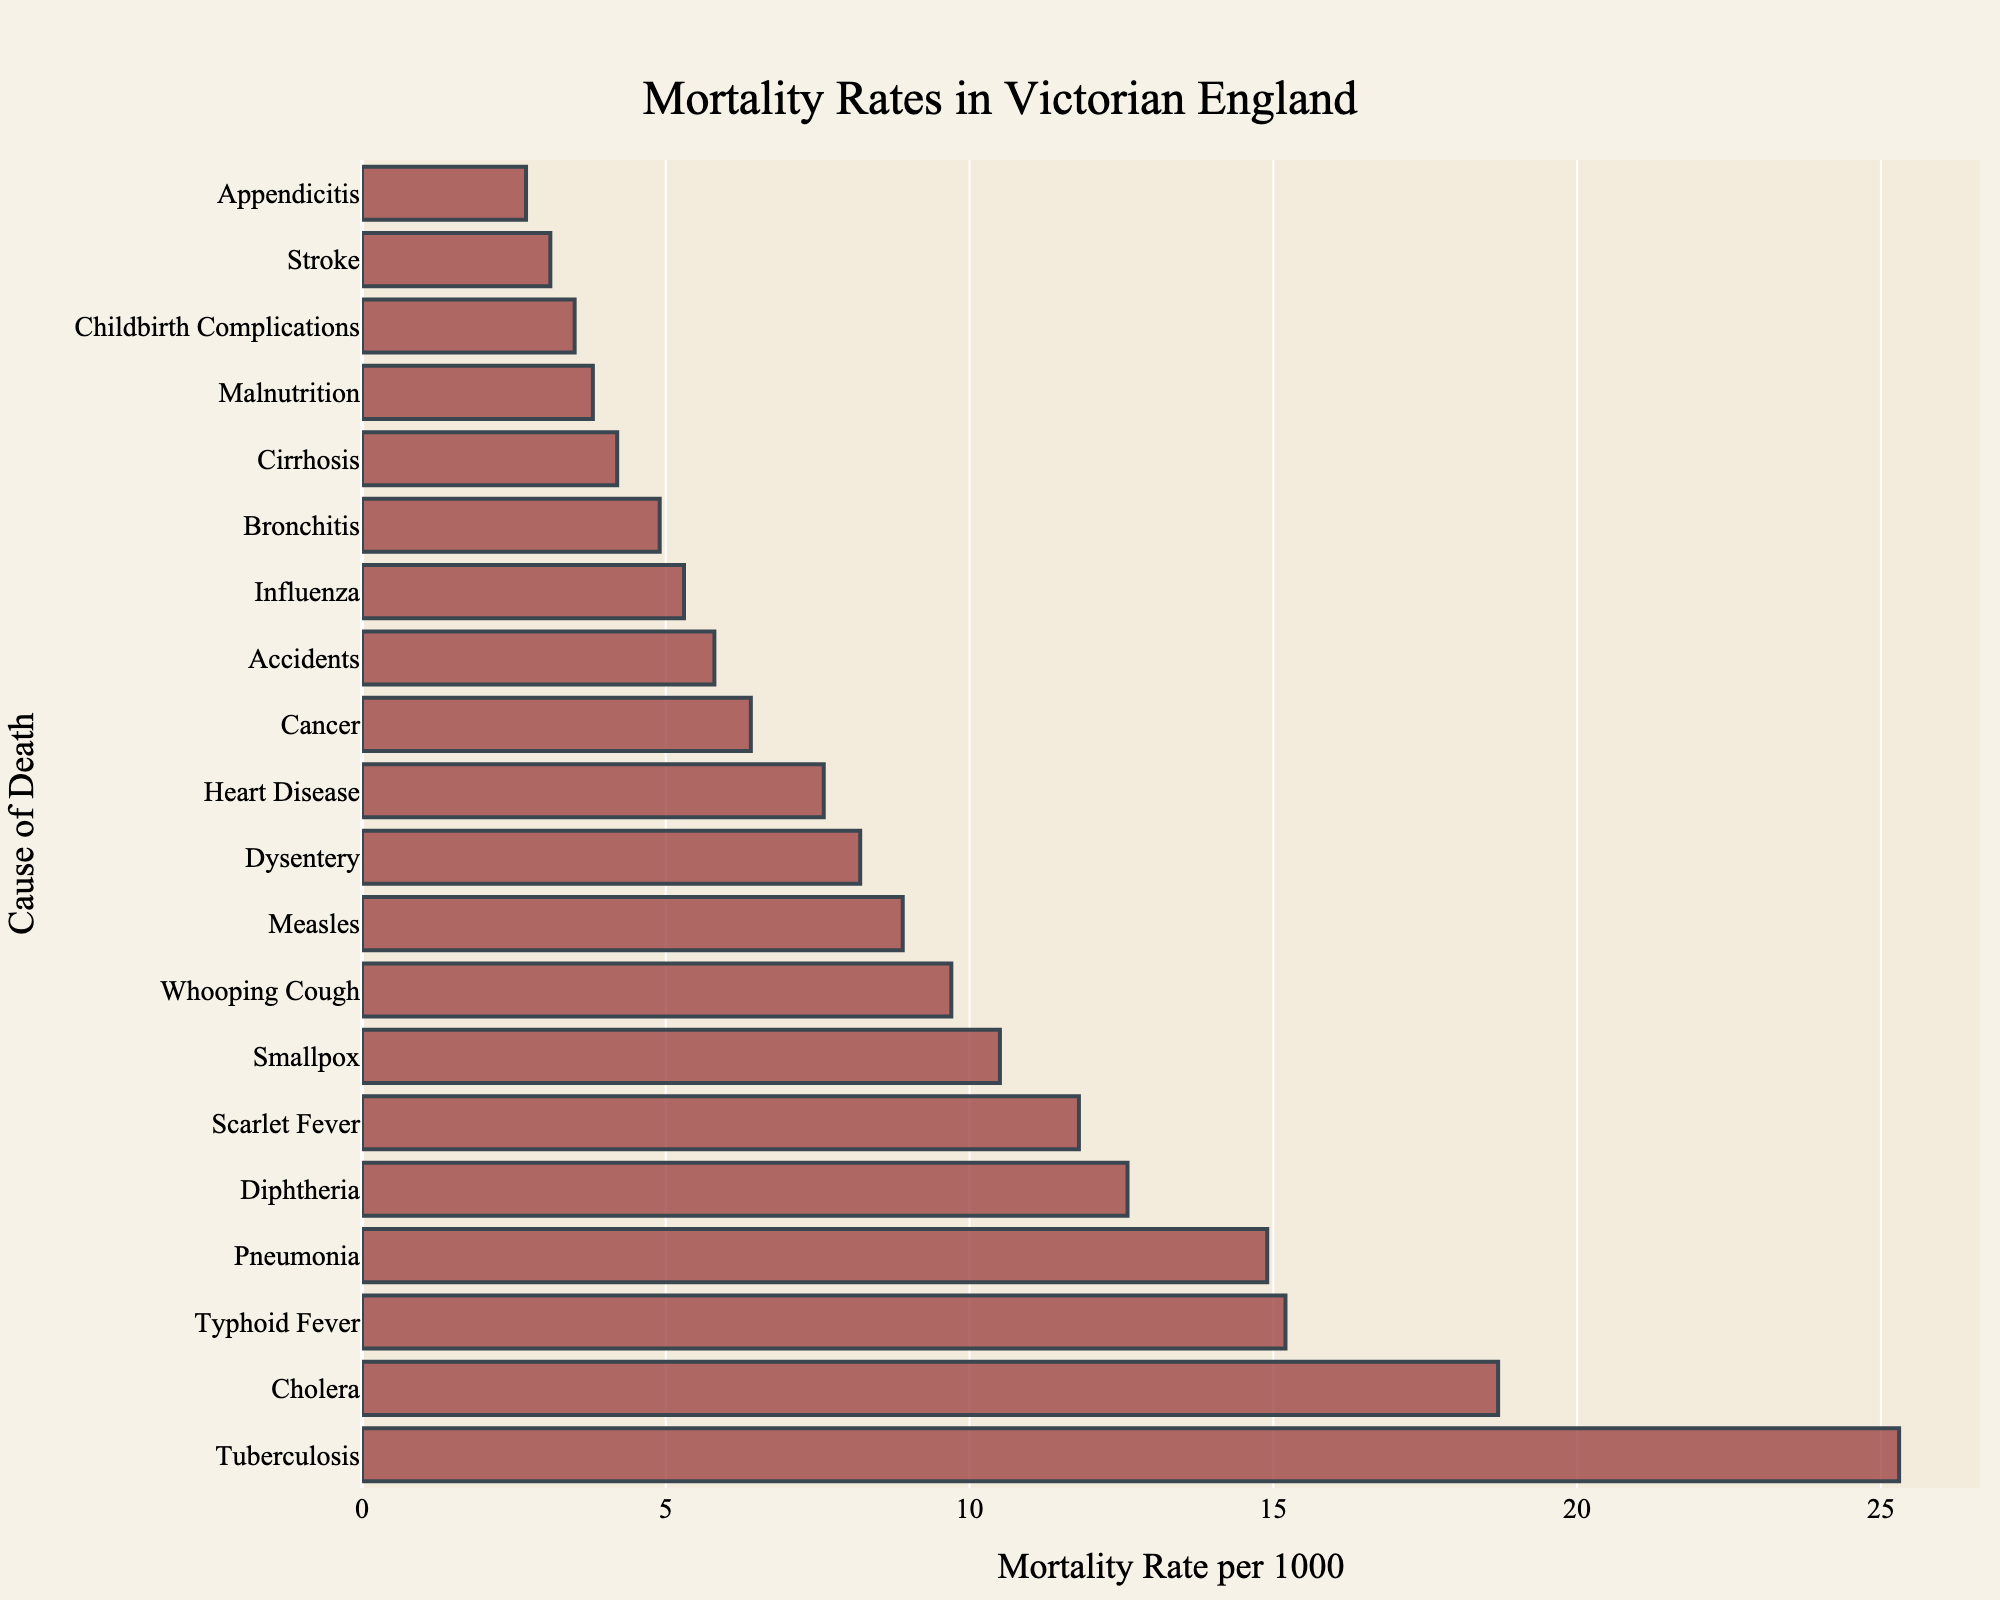Which cause of death had the highest mortality rate in Victorian England? To find which cause of death had the highest mortality rate, look for the longest bar on the chart. The longest bar represents Tuberculosis.
Answer: Tuberculosis Which cause of death had the lowest mortality rate in Victorian England? To see which cause of death had the lowest mortality rate, examine the shortest bar on the chart. The shortest bar corresponds to Appendicitis.
Answer: Appendicitis What is the total mortality rate of the top three causes of death? Sum the mortality rates of the top three causes of death (Tuberculosis, Cholera, and Typhoid Fever). These rates are 25.3, 18.7, and 15.2 respectively. Thus, the total is 25.3 + 18.7 + 15.2 = 59.2.
Answer: 59.2 How much higher is the mortality rate of Tuberculosis compared to Influenza? To compare the rates, subtract the mortality rate of Influenza (5.3) from that of Tuberculosis (25.3). Thus, 25.3 - 5.3 = 20.
Answer: 20 Comparing Pneumonia and Bronchitis, which has a higher mortality rate and by how much? Pneumonia has a mortality rate of 14.9, while Bronchitis has a rate of 4.9. Subtract the lower rate from the higher rate: 14.9 - 4.9 = 10.
Answer: Pneumonia, by 10 Of the causes listed, which two have the closest mortality rates? Identify pairs of adjacent bars with similar lengths, focusing on those in the middle of the list. The closest rates are for Pneumonia (14.9) and Typhoid Fever (15.2), with a difference of only 0.3.
Answer: Pneumonia and Typhoid Fever What is the average mortality rate of the five least deadly causes of death? The five least deadly causes are Stroke, Appendicitis, Childbirth Complications, Cirrhosis, and Malnutrition, with mortality rates of 3.1, 2.7, 3.5, 4.2, and 3.8 respectively. Sum these rates: 3.1 + 2.7 + 3.5 + 4.2 + 3.8 = 17.3. The average is 17.3 / 5 = 3.46.
Answer: 3.46 Is the mortality rate of Cancer closer to that of Heart Disease or Influenza? Compare distances: the rate of Cancer (6.4) is closer to Heart Disease (7.6), with a difference of 1.2, than to Influenza (5.3), with a difference of 1.1. Thus, Cancer is closer to Influenza (5.3).
Answer: Influenza What cumulative mortality rate do Smallpox, Whooping Cough, and Measles contribute? Add the mortality rates: Smallpox (10.5), Whooping Cough (9.7), and Measles (8.9). The sum is 10.5 + 9.7 + 8.9 = 29.1.
Answer: 29.1 Which has a higher combined mortality rate, Diphtheria and Scarlet Fever or Dysentery and Pneumonia? Sum the respective pairs of mortality rates: Diphtheria (12.6) and Scarlet Fever (11.8) give 12.6 + 11.8 = 24.4; Dysentery (8.2) and Pneumonia (14.9) give 8.2 + 14.9 = 23.1. Diphtheria and Scarlet Fever have the higher combined rate.
Answer: Diphtheria and Scarlet Fever 